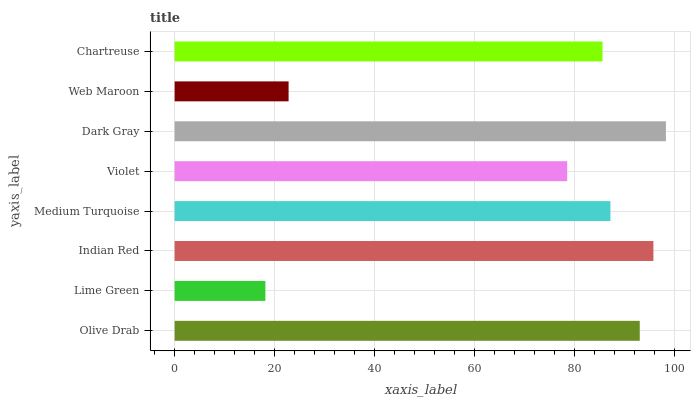Is Lime Green the minimum?
Answer yes or no. Yes. Is Dark Gray the maximum?
Answer yes or no. Yes. Is Indian Red the minimum?
Answer yes or no. No. Is Indian Red the maximum?
Answer yes or no. No. Is Indian Red greater than Lime Green?
Answer yes or no. Yes. Is Lime Green less than Indian Red?
Answer yes or no. Yes. Is Lime Green greater than Indian Red?
Answer yes or no. No. Is Indian Red less than Lime Green?
Answer yes or no. No. Is Medium Turquoise the high median?
Answer yes or no. Yes. Is Chartreuse the low median?
Answer yes or no. Yes. Is Dark Gray the high median?
Answer yes or no. No. Is Violet the low median?
Answer yes or no. No. 